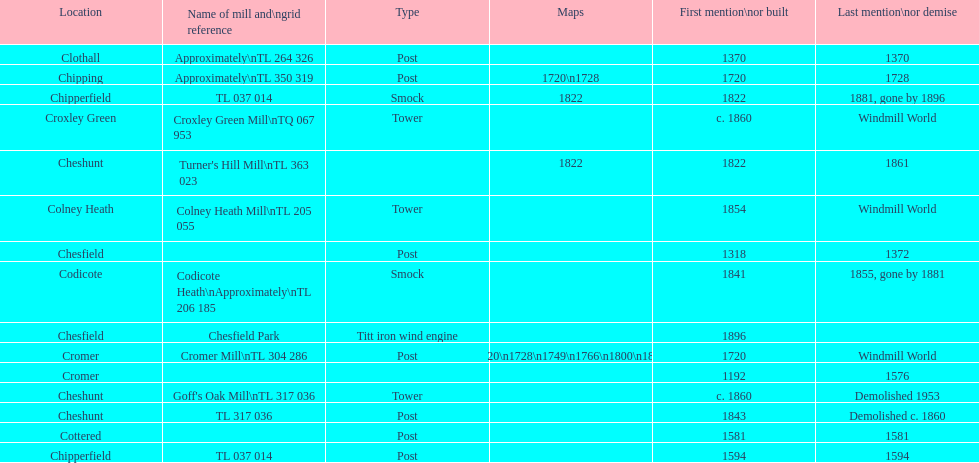How many locations have or had at least 2 windmills? 4. Could you parse the entire table? {'header': ['Location', 'Name of mill and\\ngrid reference', 'Type', 'Maps', 'First mention\\nor built', 'Last mention\\nor demise'], 'rows': [['Clothall', 'Approximately\\nTL 264 326', 'Post', '', '1370', '1370'], ['Chipping', 'Approximately\\nTL 350 319', 'Post', '1720\\n1728', '1720', '1728'], ['Chipperfield', 'TL 037 014', 'Smock', '1822', '1822', '1881, gone by 1896'], ['Croxley Green', 'Croxley Green Mill\\nTQ 067 953', 'Tower', '', 'c. 1860', 'Windmill World'], ['Cheshunt', "Turner's Hill Mill\\nTL 363 023", '', '1822', '1822', '1861'], ['Colney Heath', 'Colney Heath Mill\\nTL 205 055', 'Tower', '', '1854', 'Windmill World'], ['Chesfield', '', 'Post', '', '1318', '1372'], ['Codicote', 'Codicote Heath\\nApproximately\\nTL 206 185', 'Smock', '', '1841', '1855, gone by 1881'], ['Chesfield', 'Chesfield Park', 'Titt iron wind engine', '', '1896', ''], ['Cromer', 'Cromer Mill\\nTL 304 286', 'Post', '1720\\n1728\\n1749\\n1766\\n1800\\n1822', '1720', 'Windmill World'], ['Cromer', '', '', '', '1192', '1576'], ['Cheshunt', "Goff's Oak Mill\\nTL 317 036", 'Tower', '', 'c. 1860', 'Demolished 1953'], ['Cheshunt', 'TL 317 036', 'Post', '', '1843', 'Demolished c. 1860'], ['Cottered', '', 'Post', '', '1581', '1581'], ['Chipperfield', 'TL 037 014', 'Post', '', '1594', '1594']]} 